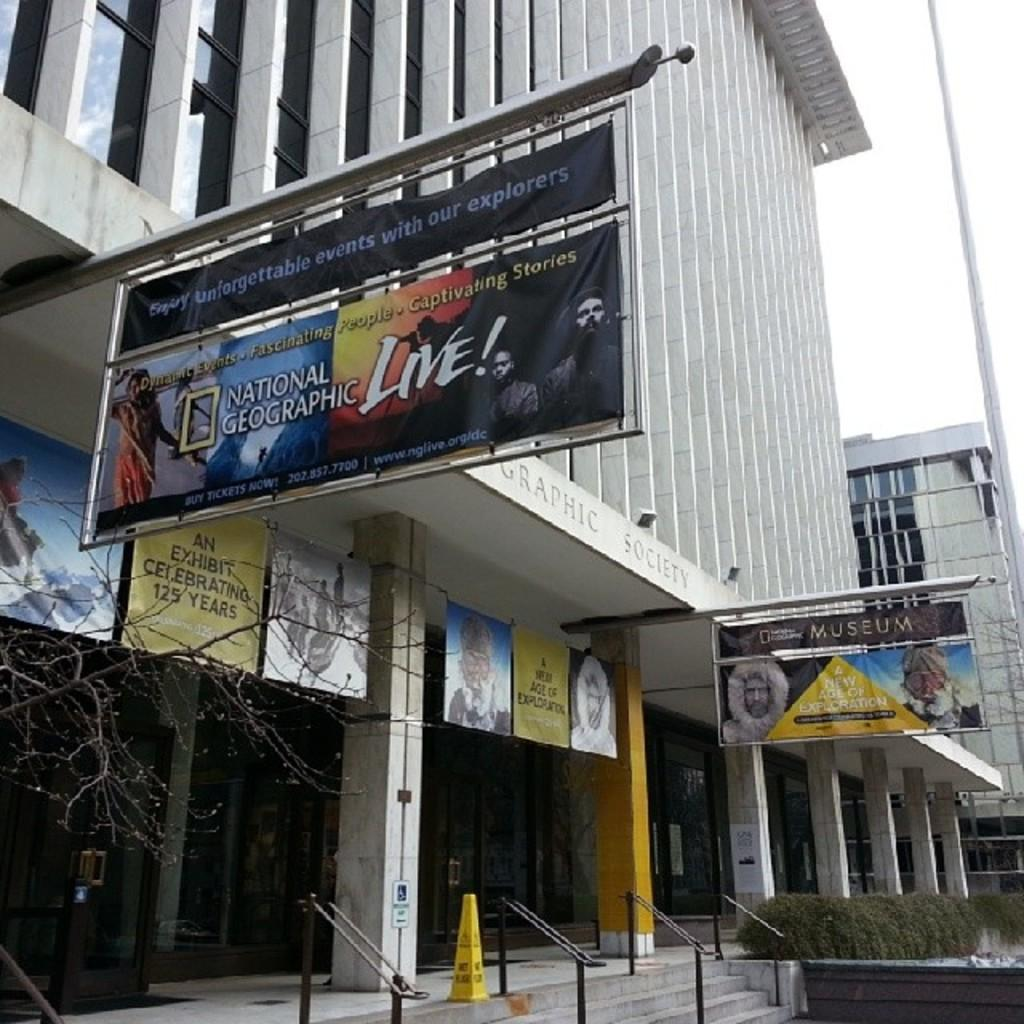<image>
Summarize the visual content of the image. A billboard sign for National Geographic going live 